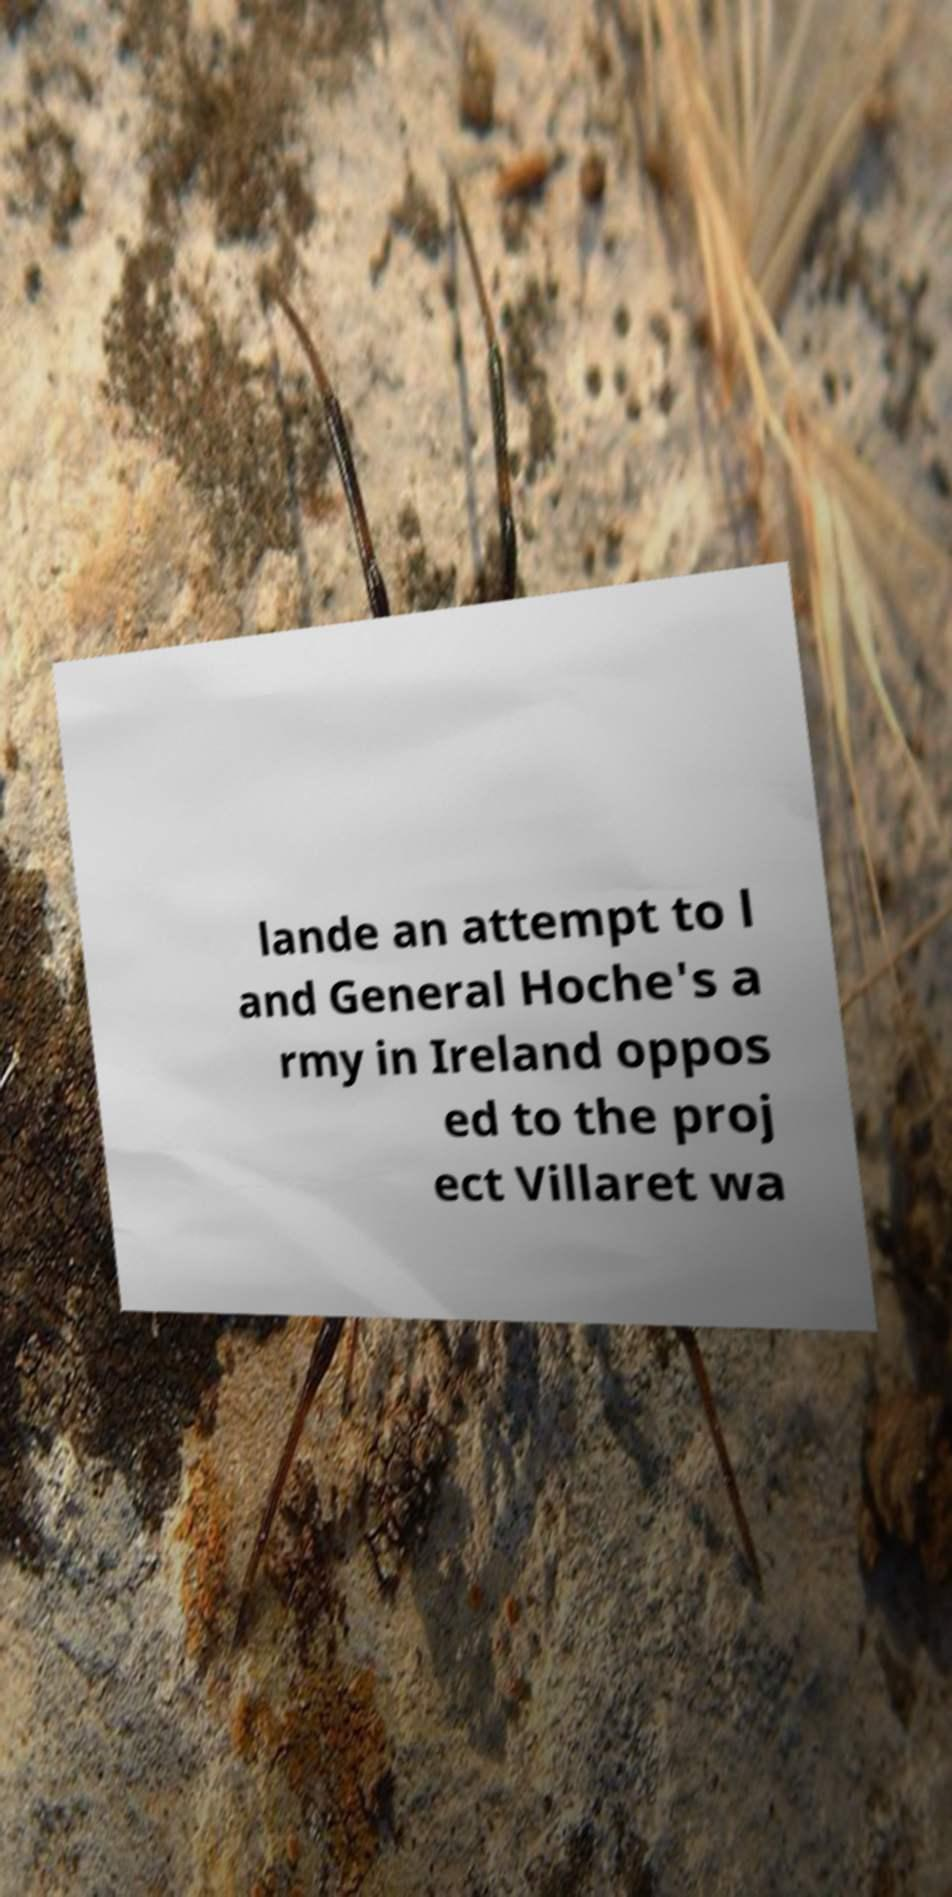Could you assist in decoding the text presented in this image and type it out clearly? lande an attempt to l and General Hoche's a rmy in Ireland oppos ed to the proj ect Villaret wa 